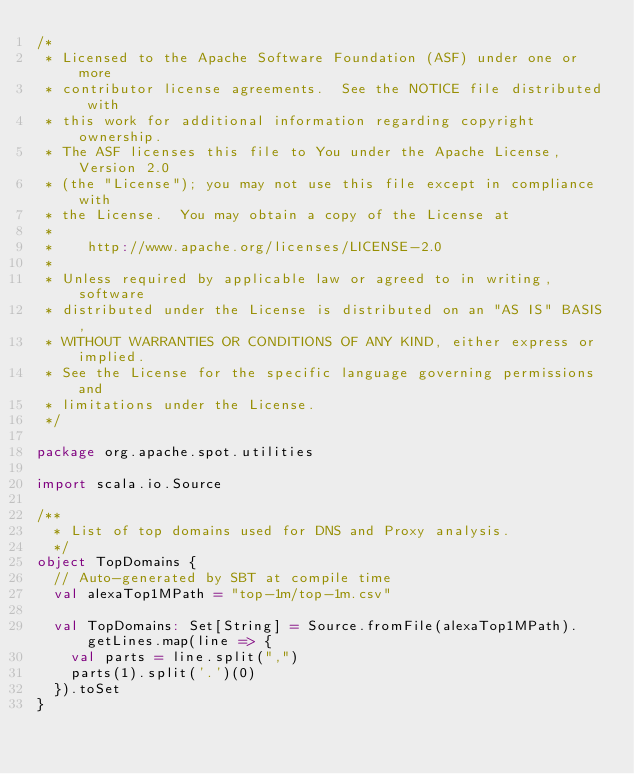<code> <loc_0><loc_0><loc_500><loc_500><_Scala_>/*
 * Licensed to the Apache Software Foundation (ASF) under one or more
 * contributor license agreements.  See the NOTICE file distributed with
 * this work for additional information regarding copyright ownership.
 * The ASF licenses this file to You under the Apache License, Version 2.0
 * (the "License"); you may not use this file except in compliance with
 * the License.  You may obtain a copy of the License at
 *
 *    http://www.apache.org/licenses/LICENSE-2.0
 *
 * Unless required by applicable law or agreed to in writing, software
 * distributed under the License is distributed on an "AS IS" BASIS,
 * WITHOUT WARRANTIES OR CONDITIONS OF ANY KIND, either express or implied.
 * See the License for the specific language governing permissions and
 * limitations under the License.
 */

package org.apache.spot.utilities

import scala.io.Source

/**
  * List of top domains used for DNS and Proxy analysis.
  */
object TopDomains {
  // Auto-generated by SBT at compile time
  val alexaTop1MPath = "top-1m/top-1m.csv"

  val TopDomains: Set[String] = Source.fromFile(alexaTop1MPath).getLines.map(line => {
    val parts = line.split(",")
    parts(1).split('.')(0)
  }).toSet
}
</code> 